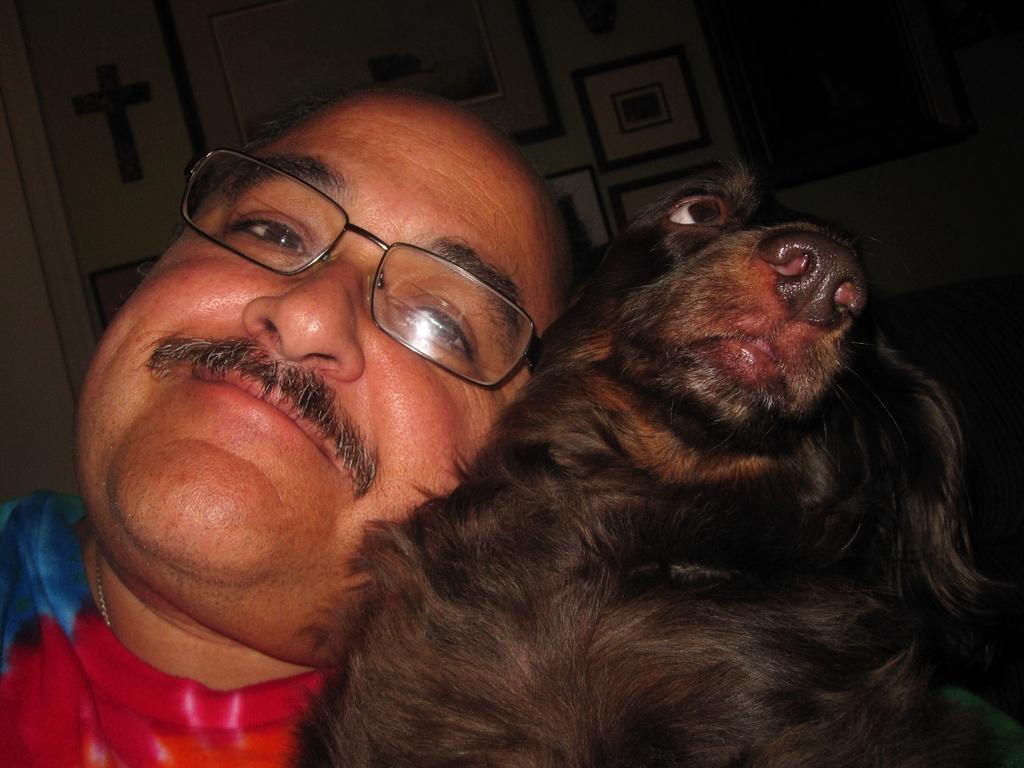Please provide a concise description of this image. In this picture i could see a person beside a black color dog having mustaches and glasses on him. Up in the ceiling there is a beautiful design. 